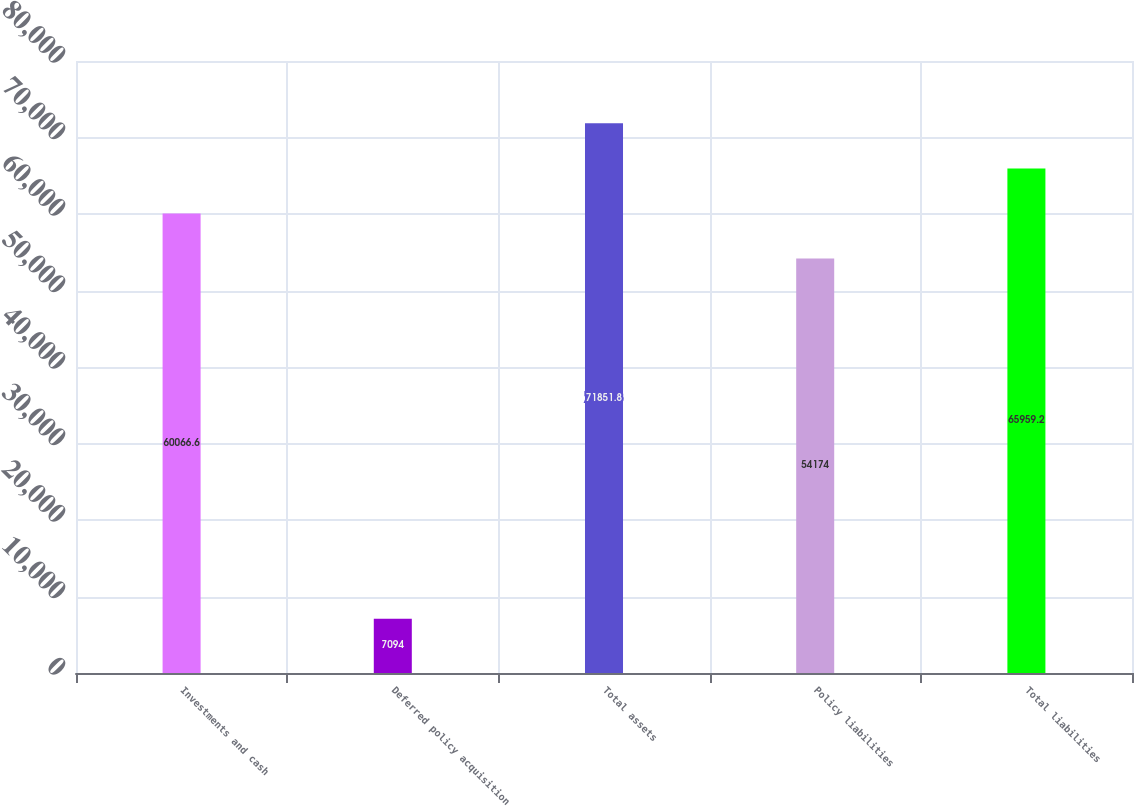Convert chart. <chart><loc_0><loc_0><loc_500><loc_500><bar_chart><fcel>Investments and cash<fcel>Deferred policy acquisition<fcel>Total assets<fcel>Policy liabilities<fcel>Total liabilities<nl><fcel>60066.6<fcel>7094<fcel>71851.8<fcel>54174<fcel>65959.2<nl></chart> 